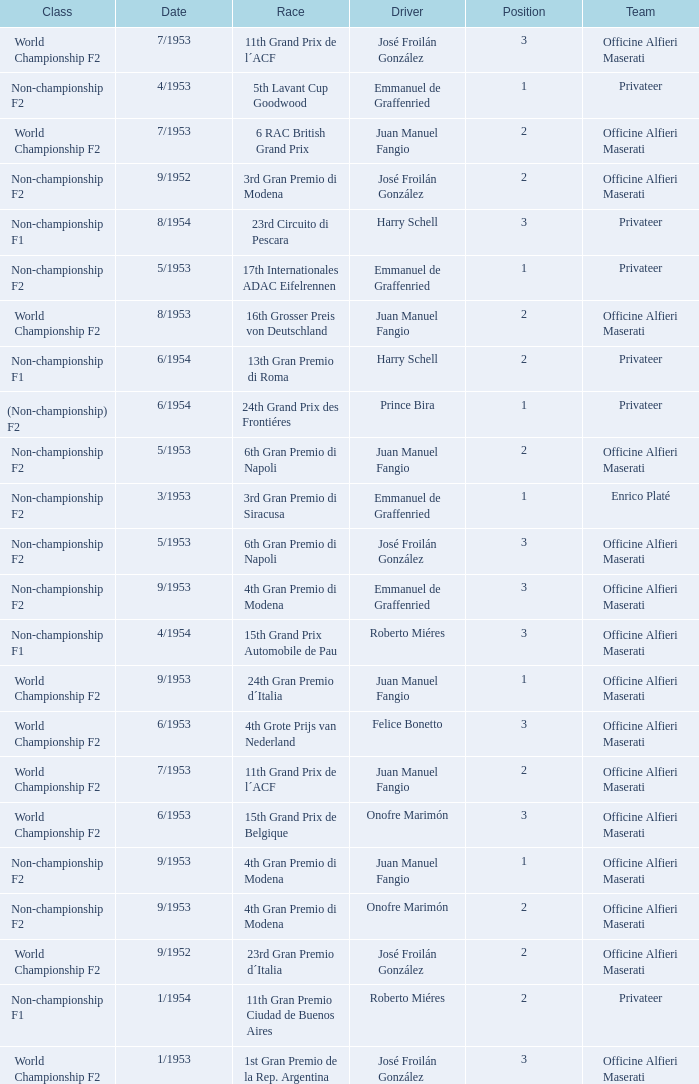What date has the class of non-championship f2 as well as a driver name josé froilán gonzález that has a position larger than 2? 5/1953. Would you mind parsing the complete table? {'header': ['Class', 'Date', 'Race', 'Driver', 'Position', 'Team'], 'rows': [['World Championship F2', '7/1953', '11th Grand Prix de l´ACF', 'José Froilán González', '3', 'Officine Alfieri Maserati'], ['Non-championship F2', '4/1953', '5th Lavant Cup Goodwood', 'Emmanuel de Graffenried', '1', 'Privateer'], ['World Championship F2', '7/1953', '6 RAC British Grand Prix', 'Juan Manuel Fangio', '2', 'Officine Alfieri Maserati'], ['Non-championship F2', '9/1952', '3rd Gran Premio di Modena', 'José Froilán González', '2', 'Officine Alfieri Maserati'], ['Non-championship F1', '8/1954', '23rd Circuito di Pescara', 'Harry Schell', '3', 'Privateer'], ['Non-championship F2', '5/1953', '17th Internationales ADAC Eifelrennen', 'Emmanuel de Graffenried', '1', 'Privateer'], ['World Championship F2', '8/1953', '16th Grosser Preis von Deutschland', 'Juan Manuel Fangio', '2', 'Officine Alfieri Maserati'], ['Non-championship F1', '6/1954', '13th Gran Premio di Roma', 'Harry Schell', '2', 'Privateer'], ['(Non-championship) F2', '6/1954', '24th Grand Prix des Frontiéres', 'Prince Bira', '1', 'Privateer'], ['Non-championship F2', '5/1953', '6th Gran Premio di Napoli', 'Juan Manuel Fangio', '2', 'Officine Alfieri Maserati'], ['Non-championship F2', '3/1953', '3rd Gran Premio di Siracusa', 'Emmanuel de Graffenried', '1', 'Enrico Platé'], ['Non-championship F2', '5/1953', '6th Gran Premio di Napoli', 'José Froilán González', '3', 'Officine Alfieri Maserati'], ['Non-championship F2', '9/1953', '4th Gran Premio di Modena', 'Emmanuel de Graffenried', '3', 'Officine Alfieri Maserati'], ['Non-championship F1', '4/1954', '15th Grand Prix Automobile de Pau', 'Roberto Miéres', '3', 'Officine Alfieri Maserati'], ['World Championship F2', '9/1953', '24th Gran Premio d´Italia', 'Juan Manuel Fangio', '1', 'Officine Alfieri Maserati'], ['World Championship F2', '6/1953', '4th Grote Prijs van Nederland', 'Felice Bonetto', '3', 'Officine Alfieri Maserati'], ['World Championship F2', '7/1953', '11th Grand Prix de l´ACF', 'Juan Manuel Fangio', '2', 'Officine Alfieri Maserati'], ['World Championship F2', '6/1953', '15th Grand Prix de Belgique', 'Onofre Marimón', '3', 'Officine Alfieri Maserati'], ['Non-championship F2', '9/1953', '4th Gran Premio di Modena', 'Juan Manuel Fangio', '1', 'Officine Alfieri Maserati'], ['Non-championship F2', '9/1953', '4th Gran Premio di Modena', 'Onofre Marimón', '2', 'Officine Alfieri Maserati'], ['World Championship F2', '9/1952', '23rd Gran Premio d´Italia', 'José Froilán González', '2', 'Officine Alfieri Maserati'], ['Non-championship F1', '1/1954', '11th Gran Premio Ciudad de Buenos Aires', 'Roberto Miéres', '2', 'Privateer'], ['World Championship F2', '1/1953', '1st Gran Premio de la Rep. Argentina', 'José Froilán González', '3', 'Officine Alfieri Maserati']]} 